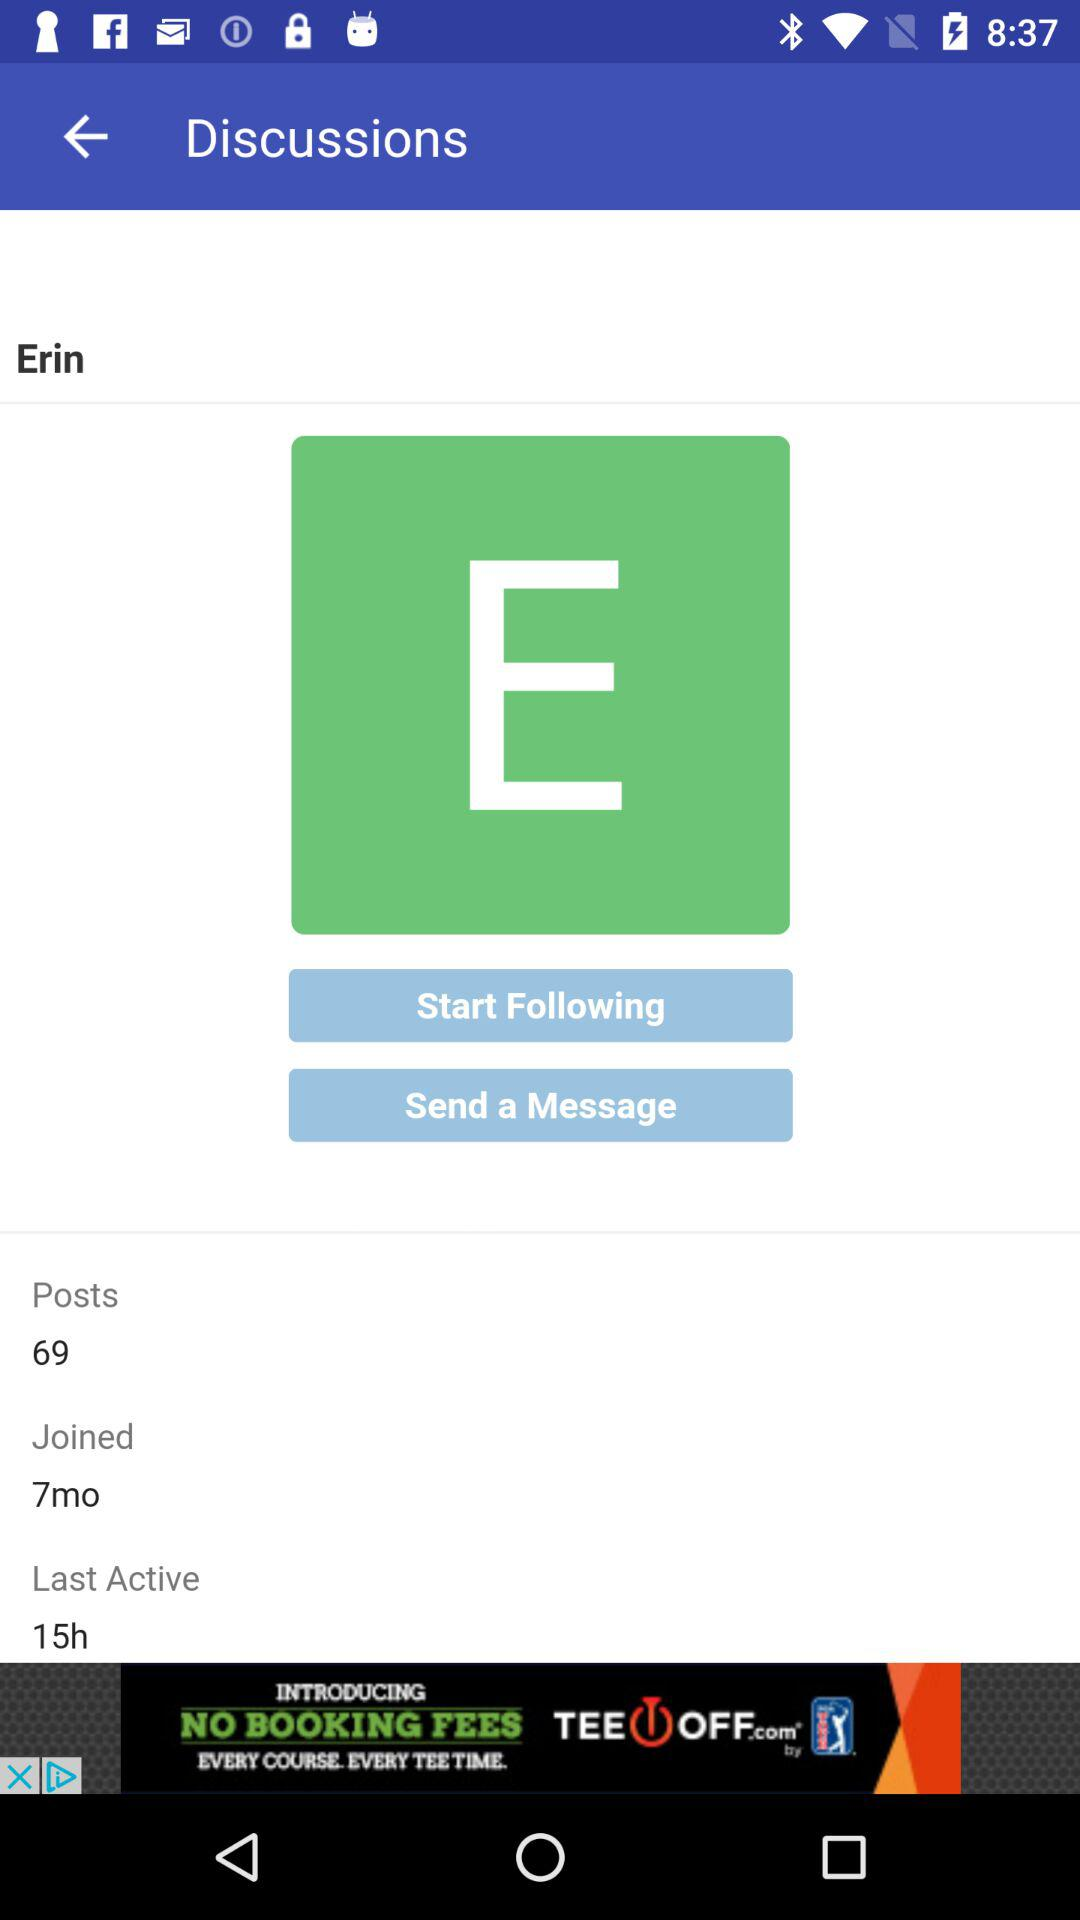How many posts are there? There are 69 posts. 